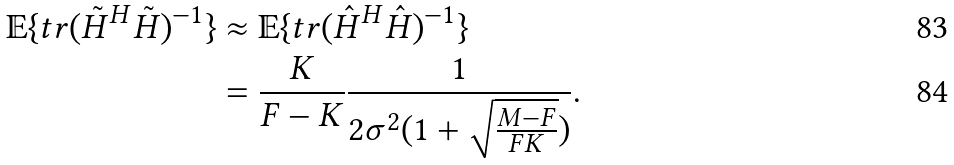<formula> <loc_0><loc_0><loc_500><loc_500>\mathbb { E } \{ t r ( \tilde { H } ^ { H } \tilde { H } ) ^ { - 1 } \} & \approx \mathbb { E } \{ t r ( \hat { H } ^ { H } \hat { H } ) ^ { - 1 } \} \\ & = \frac { K } { F - K } \frac { 1 } { 2 \sigma ^ { 2 } ( 1 + \sqrt { \frac { M - F } { F K } } ) } .</formula> 